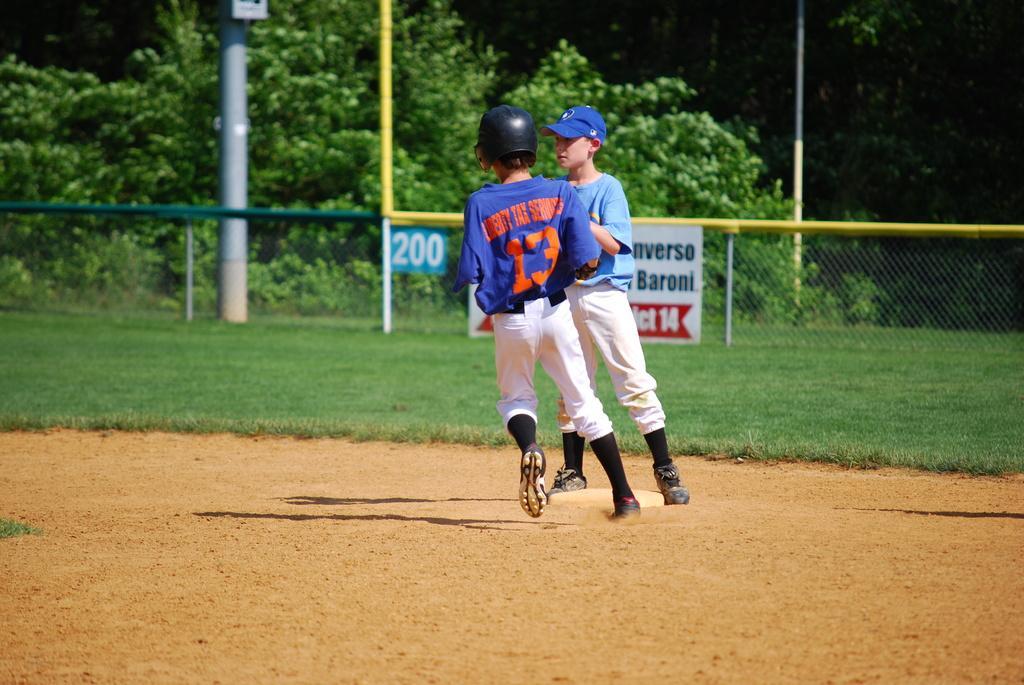Could you give a brief overview of what you see in this image? In this image there are two kids, on the surface there is a disk, behind the kids there is grass, a mesh fence on the fence there is a number and a banner, behind the fence there are poles and trees. 